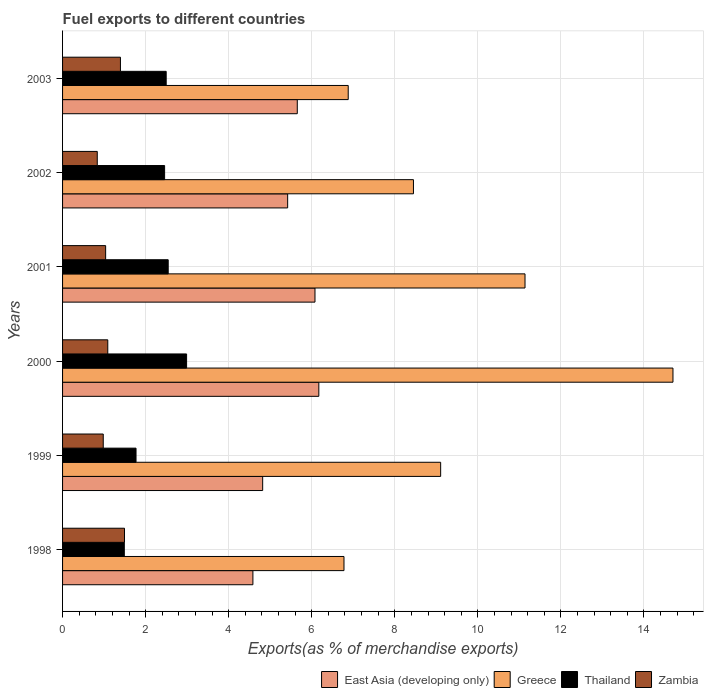How many bars are there on the 1st tick from the top?
Keep it short and to the point. 4. How many bars are there on the 4th tick from the bottom?
Offer a very short reply. 4. What is the percentage of exports to different countries in Greece in 1998?
Ensure brevity in your answer.  6.78. Across all years, what is the maximum percentage of exports to different countries in Thailand?
Keep it short and to the point. 2.99. Across all years, what is the minimum percentage of exports to different countries in Zambia?
Your response must be concise. 0.84. In which year was the percentage of exports to different countries in East Asia (developing only) minimum?
Keep it short and to the point. 1998. What is the total percentage of exports to different countries in Zambia in the graph?
Your answer should be compact. 6.83. What is the difference between the percentage of exports to different countries in East Asia (developing only) in 2001 and that in 2002?
Ensure brevity in your answer.  0.66. What is the difference between the percentage of exports to different countries in Zambia in 1998 and the percentage of exports to different countries in East Asia (developing only) in 2002?
Your answer should be compact. -3.93. What is the average percentage of exports to different countries in Zambia per year?
Your answer should be very brief. 1.14. In the year 2000, what is the difference between the percentage of exports to different countries in Greece and percentage of exports to different countries in Zambia?
Ensure brevity in your answer.  13.61. What is the ratio of the percentage of exports to different countries in Thailand in 1999 to that in 2002?
Give a very brief answer. 0.72. Is the percentage of exports to different countries in East Asia (developing only) in 1999 less than that in 2003?
Ensure brevity in your answer.  Yes. What is the difference between the highest and the second highest percentage of exports to different countries in Thailand?
Your answer should be compact. 0.44. What is the difference between the highest and the lowest percentage of exports to different countries in East Asia (developing only)?
Your answer should be compact. 1.59. In how many years, is the percentage of exports to different countries in East Asia (developing only) greater than the average percentage of exports to different countries in East Asia (developing only) taken over all years?
Give a very brief answer. 3. Is the sum of the percentage of exports to different countries in East Asia (developing only) in 1998 and 2002 greater than the maximum percentage of exports to different countries in Zambia across all years?
Give a very brief answer. Yes. Is it the case that in every year, the sum of the percentage of exports to different countries in East Asia (developing only) and percentage of exports to different countries in Greece is greater than the sum of percentage of exports to different countries in Thailand and percentage of exports to different countries in Zambia?
Your response must be concise. Yes. What does the 4th bar from the top in 1998 represents?
Offer a very short reply. East Asia (developing only). What does the 4th bar from the bottom in 2000 represents?
Offer a terse response. Zambia. Are all the bars in the graph horizontal?
Your answer should be very brief. Yes. How many years are there in the graph?
Ensure brevity in your answer.  6. What is the difference between two consecutive major ticks on the X-axis?
Your answer should be compact. 2. Does the graph contain grids?
Make the answer very short. Yes. How many legend labels are there?
Offer a terse response. 4. What is the title of the graph?
Give a very brief answer. Fuel exports to different countries. What is the label or title of the X-axis?
Ensure brevity in your answer.  Exports(as % of merchandise exports). What is the label or title of the Y-axis?
Provide a short and direct response. Years. What is the Exports(as % of merchandise exports) of East Asia (developing only) in 1998?
Provide a short and direct response. 4.58. What is the Exports(as % of merchandise exports) of Greece in 1998?
Ensure brevity in your answer.  6.78. What is the Exports(as % of merchandise exports) in Thailand in 1998?
Give a very brief answer. 1.49. What is the Exports(as % of merchandise exports) in Zambia in 1998?
Your response must be concise. 1.49. What is the Exports(as % of merchandise exports) of East Asia (developing only) in 1999?
Ensure brevity in your answer.  4.82. What is the Exports(as % of merchandise exports) of Greece in 1999?
Your answer should be very brief. 9.1. What is the Exports(as % of merchandise exports) of Thailand in 1999?
Give a very brief answer. 1.77. What is the Exports(as % of merchandise exports) in Zambia in 1999?
Provide a succinct answer. 0.98. What is the Exports(as % of merchandise exports) in East Asia (developing only) in 2000?
Offer a terse response. 6.17. What is the Exports(as % of merchandise exports) of Greece in 2000?
Give a very brief answer. 14.7. What is the Exports(as % of merchandise exports) of Thailand in 2000?
Make the answer very short. 2.99. What is the Exports(as % of merchandise exports) of Zambia in 2000?
Provide a short and direct response. 1.09. What is the Exports(as % of merchandise exports) of East Asia (developing only) in 2001?
Offer a terse response. 6.08. What is the Exports(as % of merchandise exports) of Greece in 2001?
Give a very brief answer. 11.14. What is the Exports(as % of merchandise exports) in Thailand in 2001?
Give a very brief answer. 2.54. What is the Exports(as % of merchandise exports) of Zambia in 2001?
Offer a very short reply. 1.04. What is the Exports(as % of merchandise exports) of East Asia (developing only) in 2002?
Your response must be concise. 5.42. What is the Exports(as % of merchandise exports) of Greece in 2002?
Offer a very short reply. 8.45. What is the Exports(as % of merchandise exports) of Thailand in 2002?
Offer a terse response. 2.46. What is the Exports(as % of merchandise exports) in Zambia in 2002?
Give a very brief answer. 0.84. What is the Exports(as % of merchandise exports) of East Asia (developing only) in 2003?
Make the answer very short. 5.65. What is the Exports(as % of merchandise exports) of Greece in 2003?
Keep it short and to the point. 6.88. What is the Exports(as % of merchandise exports) in Thailand in 2003?
Your answer should be very brief. 2.5. What is the Exports(as % of merchandise exports) in Zambia in 2003?
Ensure brevity in your answer.  1.39. Across all years, what is the maximum Exports(as % of merchandise exports) of East Asia (developing only)?
Your response must be concise. 6.17. Across all years, what is the maximum Exports(as % of merchandise exports) of Greece?
Offer a terse response. 14.7. Across all years, what is the maximum Exports(as % of merchandise exports) in Thailand?
Offer a very short reply. 2.99. Across all years, what is the maximum Exports(as % of merchandise exports) in Zambia?
Give a very brief answer. 1.49. Across all years, what is the minimum Exports(as % of merchandise exports) of East Asia (developing only)?
Give a very brief answer. 4.58. Across all years, what is the minimum Exports(as % of merchandise exports) of Greece?
Offer a terse response. 6.78. Across all years, what is the minimum Exports(as % of merchandise exports) of Thailand?
Your answer should be very brief. 1.49. Across all years, what is the minimum Exports(as % of merchandise exports) of Zambia?
Your answer should be very brief. 0.84. What is the total Exports(as % of merchandise exports) of East Asia (developing only) in the graph?
Make the answer very short. 32.72. What is the total Exports(as % of merchandise exports) of Greece in the graph?
Provide a short and direct response. 57.04. What is the total Exports(as % of merchandise exports) of Thailand in the graph?
Your response must be concise. 13.74. What is the total Exports(as % of merchandise exports) of Zambia in the graph?
Keep it short and to the point. 6.83. What is the difference between the Exports(as % of merchandise exports) of East Asia (developing only) in 1998 and that in 1999?
Provide a succinct answer. -0.24. What is the difference between the Exports(as % of merchandise exports) of Greece in 1998 and that in 1999?
Offer a terse response. -2.33. What is the difference between the Exports(as % of merchandise exports) in Thailand in 1998 and that in 1999?
Give a very brief answer. -0.28. What is the difference between the Exports(as % of merchandise exports) in Zambia in 1998 and that in 1999?
Your answer should be compact. 0.51. What is the difference between the Exports(as % of merchandise exports) in East Asia (developing only) in 1998 and that in 2000?
Give a very brief answer. -1.59. What is the difference between the Exports(as % of merchandise exports) of Greece in 1998 and that in 2000?
Ensure brevity in your answer.  -7.92. What is the difference between the Exports(as % of merchandise exports) in Thailand in 1998 and that in 2000?
Make the answer very short. -1.5. What is the difference between the Exports(as % of merchandise exports) in Zambia in 1998 and that in 2000?
Provide a succinct answer. 0.4. What is the difference between the Exports(as % of merchandise exports) of East Asia (developing only) in 1998 and that in 2001?
Make the answer very short. -1.5. What is the difference between the Exports(as % of merchandise exports) of Greece in 1998 and that in 2001?
Your answer should be compact. -4.36. What is the difference between the Exports(as % of merchandise exports) in Thailand in 1998 and that in 2001?
Provide a succinct answer. -1.06. What is the difference between the Exports(as % of merchandise exports) of Zambia in 1998 and that in 2001?
Keep it short and to the point. 0.45. What is the difference between the Exports(as % of merchandise exports) of East Asia (developing only) in 1998 and that in 2002?
Your response must be concise. -0.84. What is the difference between the Exports(as % of merchandise exports) of Greece in 1998 and that in 2002?
Provide a succinct answer. -1.67. What is the difference between the Exports(as % of merchandise exports) in Thailand in 1998 and that in 2002?
Ensure brevity in your answer.  -0.97. What is the difference between the Exports(as % of merchandise exports) of Zambia in 1998 and that in 2002?
Keep it short and to the point. 0.66. What is the difference between the Exports(as % of merchandise exports) in East Asia (developing only) in 1998 and that in 2003?
Offer a very short reply. -1.07. What is the difference between the Exports(as % of merchandise exports) of Greece in 1998 and that in 2003?
Offer a terse response. -0.1. What is the difference between the Exports(as % of merchandise exports) of Thailand in 1998 and that in 2003?
Provide a succinct answer. -1.01. What is the difference between the Exports(as % of merchandise exports) in Zambia in 1998 and that in 2003?
Keep it short and to the point. 0.1. What is the difference between the Exports(as % of merchandise exports) in East Asia (developing only) in 1999 and that in 2000?
Offer a very short reply. -1.35. What is the difference between the Exports(as % of merchandise exports) of Greece in 1999 and that in 2000?
Offer a very short reply. -5.59. What is the difference between the Exports(as % of merchandise exports) in Thailand in 1999 and that in 2000?
Your answer should be compact. -1.22. What is the difference between the Exports(as % of merchandise exports) in Zambia in 1999 and that in 2000?
Keep it short and to the point. -0.11. What is the difference between the Exports(as % of merchandise exports) in East Asia (developing only) in 1999 and that in 2001?
Offer a very short reply. -1.26. What is the difference between the Exports(as % of merchandise exports) of Greece in 1999 and that in 2001?
Provide a succinct answer. -2.03. What is the difference between the Exports(as % of merchandise exports) in Thailand in 1999 and that in 2001?
Provide a succinct answer. -0.77. What is the difference between the Exports(as % of merchandise exports) of Zambia in 1999 and that in 2001?
Keep it short and to the point. -0.06. What is the difference between the Exports(as % of merchandise exports) in East Asia (developing only) in 1999 and that in 2002?
Provide a short and direct response. -0.6. What is the difference between the Exports(as % of merchandise exports) in Greece in 1999 and that in 2002?
Your answer should be compact. 0.66. What is the difference between the Exports(as % of merchandise exports) in Thailand in 1999 and that in 2002?
Keep it short and to the point. -0.69. What is the difference between the Exports(as % of merchandise exports) of Zambia in 1999 and that in 2002?
Offer a terse response. 0.14. What is the difference between the Exports(as % of merchandise exports) of East Asia (developing only) in 1999 and that in 2003?
Offer a very short reply. -0.83. What is the difference between the Exports(as % of merchandise exports) of Greece in 1999 and that in 2003?
Your answer should be compact. 2.23. What is the difference between the Exports(as % of merchandise exports) of Thailand in 1999 and that in 2003?
Make the answer very short. -0.73. What is the difference between the Exports(as % of merchandise exports) in Zambia in 1999 and that in 2003?
Your answer should be very brief. -0.41. What is the difference between the Exports(as % of merchandise exports) of East Asia (developing only) in 2000 and that in 2001?
Your response must be concise. 0.09. What is the difference between the Exports(as % of merchandise exports) in Greece in 2000 and that in 2001?
Offer a very short reply. 3.56. What is the difference between the Exports(as % of merchandise exports) of Thailand in 2000 and that in 2001?
Offer a terse response. 0.44. What is the difference between the Exports(as % of merchandise exports) in Zambia in 2000 and that in 2001?
Give a very brief answer. 0.05. What is the difference between the Exports(as % of merchandise exports) of East Asia (developing only) in 2000 and that in 2002?
Provide a short and direct response. 0.75. What is the difference between the Exports(as % of merchandise exports) in Greece in 2000 and that in 2002?
Offer a terse response. 6.25. What is the difference between the Exports(as % of merchandise exports) of Thailand in 2000 and that in 2002?
Ensure brevity in your answer.  0.53. What is the difference between the Exports(as % of merchandise exports) of Zambia in 2000 and that in 2002?
Ensure brevity in your answer.  0.25. What is the difference between the Exports(as % of merchandise exports) of East Asia (developing only) in 2000 and that in 2003?
Offer a very short reply. 0.52. What is the difference between the Exports(as % of merchandise exports) in Greece in 2000 and that in 2003?
Your answer should be very brief. 7.82. What is the difference between the Exports(as % of merchandise exports) in Thailand in 2000 and that in 2003?
Provide a succinct answer. 0.49. What is the difference between the Exports(as % of merchandise exports) of Zambia in 2000 and that in 2003?
Keep it short and to the point. -0.3. What is the difference between the Exports(as % of merchandise exports) of East Asia (developing only) in 2001 and that in 2002?
Offer a terse response. 0.66. What is the difference between the Exports(as % of merchandise exports) in Greece in 2001 and that in 2002?
Provide a succinct answer. 2.69. What is the difference between the Exports(as % of merchandise exports) of Thailand in 2001 and that in 2002?
Give a very brief answer. 0.09. What is the difference between the Exports(as % of merchandise exports) of Zambia in 2001 and that in 2002?
Your answer should be compact. 0.2. What is the difference between the Exports(as % of merchandise exports) of East Asia (developing only) in 2001 and that in 2003?
Offer a very short reply. 0.43. What is the difference between the Exports(as % of merchandise exports) of Greece in 2001 and that in 2003?
Your answer should be very brief. 4.26. What is the difference between the Exports(as % of merchandise exports) of Thailand in 2001 and that in 2003?
Give a very brief answer. 0.05. What is the difference between the Exports(as % of merchandise exports) of Zambia in 2001 and that in 2003?
Provide a short and direct response. -0.36. What is the difference between the Exports(as % of merchandise exports) of East Asia (developing only) in 2002 and that in 2003?
Your response must be concise. -0.23. What is the difference between the Exports(as % of merchandise exports) in Greece in 2002 and that in 2003?
Give a very brief answer. 1.57. What is the difference between the Exports(as % of merchandise exports) of Thailand in 2002 and that in 2003?
Your answer should be compact. -0.04. What is the difference between the Exports(as % of merchandise exports) in Zambia in 2002 and that in 2003?
Make the answer very short. -0.56. What is the difference between the Exports(as % of merchandise exports) in East Asia (developing only) in 1998 and the Exports(as % of merchandise exports) in Greece in 1999?
Your response must be concise. -4.52. What is the difference between the Exports(as % of merchandise exports) of East Asia (developing only) in 1998 and the Exports(as % of merchandise exports) of Thailand in 1999?
Provide a short and direct response. 2.81. What is the difference between the Exports(as % of merchandise exports) in East Asia (developing only) in 1998 and the Exports(as % of merchandise exports) in Zambia in 1999?
Offer a very short reply. 3.6. What is the difference between the Exports(as % of merchandise exports) of Greece in 1998 and the Exports(as % of merchandise exports) of Thailand in 1999?
Your answer should be compact. 5.01. What is the difference between the Exports(as % of merchandise exports) in Greece in 1998 and the Exports(as % of merchandise exports) in Zambia in 1999?
Your answer should be very brief. 5.8. What is the difference between the Exports(as % of merchandise exports) of Thailand in 1998 and the Exports(as % of merchandise exports) of Zambia in 1999?
Ensure brevity in your answer.  0.51. What is the difference between the Exports(as % of merchandise exports) in East Asia (developing only) in 1998 and the Exports(as % of merchandise exports) in Greece in 2000?
Offer a terse response. -10.12. What is the difference between the Exports(as % of merchandise exports) in East Asia (developing only) in 1998 and the Exports(as % of merchandise exports) in Thailand in 2000?
Ensure brevity in your answer.  1.6. What is the difference between the Exports(as % of merchandise exports) of East Asia (developing only) in 1998 and the Exports(as % of merchandise exports) of Zambia in 2000?
Offer a terse response. 3.49. What is the difference between the Exports(as % of merchandise exports) of Greece in 1998 and the Exports(as % of merchandise exports) of Thailand in 2000?
Offer a terse response. 3.79. What is the difference between the Exports(as % of merchandise exports) in Greece in 1998 and the Exports(as % of merchandise exports) in Zambia in 2000?
Your answer should be very brief. 5.69. What is the difference between the Exports(as % of merchandise exports) in Thailand in 1998 and the Exports(as % of merchandise exports) in Zambia in 2000?
Ensure brevity in your answer.  0.4. What is the difference between the Exports(as % of merchandise exports) in East Asia (developing only) in 1998 and the Exports(as % of merchandise exports) in Greece in 2001?
Offer a terse response. -6.55. What is the difference between the Exports(as % of merchandise exports) in East Asia (developing only) in 1998 and the Exports(as % of merchandise exports) in Thailand in 2001?
Your answer should be very brief. 2.04. What is the difference between the Exports(as % of merchandise exports) of East Asia (developing only) in 1998 and the Exports(as % of merchandise exports) of Zambia in 2001?
Offer a very short reply. 3.55. What is the difference between the Exports(as % of merchandise exports) of Greece in 1998 and the Exports(as % of merchandise exports) of Thailand in 2001?
Provide a succinct answer. 4.23. What is the difference between the Exports(as % of merchandise exports) in Greece in 1998 and the Exports(as % of merchandise exports) in Zambia in 2001?
Your response must be concise. 5.74. What is the difference between the Exports(as % of merchandise exports) of Thailand in 1998 and the Exports(as % of merchandise exports) of Zambia in 2001?
Ensure brevity in your answer.  0.45. What is the difference between the Exports(as % of merchandise exports) in East Asia (developing only) in 1998 and the Exports(as % of merchandise exports) in Greece in 2002?
Make the answer very short. -3.87. What is the difference between the Exports(as % of merchandise exports) in East Asia (developing only) in 1998 and the Exports(as % of merchandise exports) in Thailand in 2002?
Provide a short and direct response. 2.13. What is the difference between the Exports(as % of merchandise exports) of East Asia (developing only) in 1998 and the Exports(as % of merchandise exports) of Zambia in 2002?
Offer a very short reply. 3.75. What is the difference between the Exports(as % of merchandise exports) of Greece in 1998 and the Exports(as % of merchandise exports) of Thailand in 2002?
Provide a succinct answer. 4.32. What is the difference between the Exports(as % of merchandise exports) of Greece in 1998 and the Exports(as % of merchandise exports) of Zambia in 2002?
Give a very brief answer. 5.94. What is the difference between the Exports(as % of merchandise exports) in Thailand in 1998 and the Exports(as % of merchandise exports) in Zambia in 2002?
Ensure brevity in your answer.  0.65. What is the difference between the Exports(as % of merchandise exports) of East Asia (developing only) in 1998 and the Exports(as % of merchandise exports) of Greece in 2003?
Offer a very short reply. -2.3. What is the difference between the Exports(as % of merchandise exports) of East Asia (developing only) in 1998 and the Exports(as % of merchandise exports) of Thailand in 2003?
Provide a succinct answer. 2.09. What is the difference between the Exports(as % of merchandise exports) of East Asia (developing only) in 1998 and the Exports(as % of merchandise exports) of Zambia in 2003?
Make the answer very short. 3.19. What is the difference between the Exports(as % of merchandise exports) in Greece in 1998 and the Exports(as % of merchandise exports) in Thailand in 2003?
Your answer should be compact. 4.28. What is the difference between the Exports(as % of merchandise exports) in Greece in 1998 and the Exports(as % of merchandise exports) in Zambia in 2003?
Provide a succinct answer. 5.38. What is the difference between the Exports(as % of merchandise exports) in Thailand in 1998 and the Exports(as % of merchandise exports) in Zambia in 2003?
Your answer should be compact. 0.09. What is the difference between the Exports(as % of merchandise exports) in East Asia (developing only) in 1999 and the Exports(as % of merchandise exports) in Greece in 2000?
Your answer should be very brief. -9.88. What is the difference between the Exports(as % of merchandise exports) in East Asia (developing only) in 1999 and the Exports(as % of merchandise exports) in Thailand in 2000?
Ensure brevity in your answer.  1.83. What is the difference between the Exports(as % of merchandise exports) in East Asia (developing only) in 1999 and the Exports(as % of merchandise exports) in Zambia in 2000?
Make the answer very short. 3.73. What is the difference between the Exports(as % of merchandise exports) of Greece in 1999 and the Exports(as % of merchandise exports) of Thailand in 2000?
Give a very brief answer. 6.12. What is the difference between the Exports(as % of merchandise exports) of Greece in 1999 and the Exports(as % of merchandise exports) of Zambia in 2000?
Your response must be concise. 8.02. What is the difference between the Exports(as % of merchandise exports) of Thailand in 1999 and the Exports(as % of merchandise exports) of Zambia in 2000?
Provide a short and direct response. 0.68. What is the difference between the Exports(as % of merchandise exports) of East Asia (developing only) in 1999 and the Exports(as % of merchandise exports) of Greece in 2001?
Your response must be concise. -6.32. What is the difference between the Exports(as % of merchandise exports) of East Asia (developing only) in 1999 and the Exports(as % of merchandise exports) of Thailand in 2001?
Your answer should be very brief. 2.27. What is the difference between the Exports(as % of merchandise exports) of East Asia (developing only) in 1999 and the Exports(as % of merchandise exports) of Zambia in 2001?
Your answer should be very brief. 3.78. What is the difference between the Exports(as % of merchandise exports) of Greece in 1999 and the Exports(as % of merchandise exports) of Thailand in 2001?
Your response must be concise. 6.56. What is the difference between the Exports(as % of merchandise exports) of Greece in 1999 and the Exports(as % of merchandise exports) of Zambia in 2001?
Provide a short and direct response. 8.07. What is the difference between the Exports(as % of merchandise exports) of Thailand in 1999 and the Exports(as % of merchandise exports) of Zambia in 2001?
Make the answer very short. 0.73. What is the difference between the Exports(as % of merchandise exports) in East Asia (developing only) in 1999 and the Exports(as % of merchandise exports) in Greece in 2002?
Keep it short and to the point. -3.63. What is the difference between the Exports(as % of merchandise exports) in East Asia (developing only) in 1999 and the Exports(as % of merchandise exports) in Thailand in 2002?
Offer a terse response. 2.36. What is the difference between the Exports(as % of merchandise exports) of East Asia (developing only) in 1999 and the Exports(as % of merchandise exports) of Zambia in 2002?
Offer a very short reply. 3.98. What is the difference between the Exports(as % of merchandise exports) of Greece in 1999 and the Exports(as % of merchandise exports) of Thailand in 2002?
Give a very brief answer. 6.65. What is the difference between the Exports(as % of merchandise exports) in Greece in 1999 and the Exports(as % of merchandise exports) in Zambia in 2002?
Offer a very short reply. 8.27. What is the difference between the Exports(as % of merchandise exports) in Thailand in 1999 and the Exports(as % of merchandise exports) in Zambia in 2002?
Keep it short and to the point. 0.93. What is the difference between the Exports(as % of merchandise exports) in East Asia (developing only) in 1999 and the Exports(as % of merchandise exports) in Greece in 2003?
Provide a succinct answer. -2.06. What is the difference between the Exports(as % of merchandise exports) of East Asia (developing only) in 1999 and the Exports(as % of merchandise exports) of Thailand in 2003?
Your answer should be compact. 2.32. What is the difference between the Exports(as % of merchandise exports) in East Asia (developing only) in 1999 and the Exports(as % of merchandise exports) in Zambia in 2003?
Provide a short and direct response. 3.42. What is the difference between the Exports(as % of merchandise exports) of Greece in 1999 and the Exports(as % of merchandise exports) of Thailand in 2003?
Keep it short and to the point. 6.61. What is the difference between the Exports(as % of merchandise exports) of Greece in 1999 and the Exports(as % of merchandise exports) of Zambia in 2003?
Offer a terse response. 7.71. What is the difference between the Exports(as % of merchandise exports) in Thailand in 1999 and the Exports(as % of merchandise exports) in Zambia in 2003?
Your answer should be very brief. 0.38. What is the difference between the Exports(as % of merchandise exports) of East Asia (developing only) in 2000 and the Exports(as % of merchandise exports) of Greece in 2001?
Your answer should be compact. -4.96. What is the difference between the Exports(as % of merchandise exports) of East Asia (developing only) in 2000 and the Exports(as % of merchandise exports) of Thailand in 2001?
Provide a succinct answer. 3.63. What is the difference between the Exports(as % of merchandise exports) in East Asia (developing only) in 2000 and the Exports(as % of merchandise exports) in Zambia in 2001?
Provide a short and direct response. 5.13. What is the difference between the Exports(as % of merchandise exports) in Greece in 2000 and the Exports(as % of merchandise exports) in Thailand in 2001?
Provide a succinct answer. 12.15. What is the difference between the Exports(as % of merchandise exports) of Greece in 2000 and the Exports(as % of merchandise exports) of Zambia in 2001?
Your response must be concise. 13.66. What is the difference between the Exports(as % of merchandise exports) of Thailand in 2000 and the Exports(as % of merchandise exports) of Zambia in 2001?
Keep it short and to the point. 1.95. What is the difference between the Exports(as % of merchandise exports) in East Asia (developing only) in 2000 and the Exports(as % of merchandise exports) in Greece in 2002?
Ensure brevity in your answer.  -2.28. What is the difference between the Exports(as % of merchandise exports) in East Asia (developing only) in 2000 and the Exports(as % of merchandise exports) in Thailand in 2002?
Your answer should be compact. 3.71. What is the difference between the Exports(as % of merchandise exports) in East Asia (developing only) in 2000 and the Exports(as % of merchandise exports) in Zambia in 2002?
Your answer should be very brief. 5.33. What is the difference between the Exports(as % of merchandise exports) of Greece in 2000 and the Exports(as % of merchandise exports) of Thailand in 2002?
Offer a very short reply. 12.24. What is the difference between the Exports(as % of merchandise exports) in Greece in 2000 and the Exports(as % of merchandise exports) in Zambia in 2002?
Your response must be concise. 13.86. What is the difference between the Exports(as % of merchandise exports) in Thailand in 2000 and the Exports(as % of merchandise exports) in Zambia in 2002?
Offer a very short reply. 2.15. What is the difference between the Exports(as % of merchandise exports) of East Asia (developing only) in 2000 and the Exports(as % of merchandise exports) of Greece in 2003?
Provide a succinct answer. -0.71. What is the difference between the Exports(as % of merchandise exports) in East Asia (developing only) in 2000 and the Exports(as % of merchandise exports) in Thailand in 2003?
Keep it short and to the point. 3.68. What is the difference between the Exports(as % of merchandise exports) of East Asia (developing only) in 2000 and the Exports(as % of merchandise exports) of Zambia in 2003?
Make the answer very short. 4.78. What is the difference between the Exports(as % of merchandise exports) of Greece in 2000 and the Exports(as % of merchandise exports) of Thailand in 2003?
Offer a very short reply. 12.2. What is the difference between the Exports(as % of merchandise exports) in Greece in 2000 and the Exports(as % of merchandise exports) in Zambia in 2003?
Ensure brevity in your answer.  13.3. What is the difference between the Exports(as % of merchandise exports) of Thailand in 2000 and the Exports(as % of merchandise exports) of Zambia in 2003?
Offer a terse response. 1.59. What is the difference between the Exports(as % of merchandise exports) in East Asia (developing only) in 2001 and the Exports(as % of merchandise exports) in Greece in 2002?
Offer a very short reply. -2.37. What is the difference between the Exports(as % of merchandise exports) in East Asia (developing only) in 2001 and the Exports(as % of merchandise exports) in Thailand in 2002?
Keep it short and to the point. 3.62. What is the difference between the Exports(as % of merchandise exports) in East Asia (developing only) in 2001 and the Exports(as % of merchandise exports) in Zambia in 2002?
Your response must be concise. 5.24. What is the difference between the Exports(as % of merchandise exports) of Greece in 2001 and the Exports(as % of merchandise exports) of Thailand in 2002?
Your answer should be compact. 8.68. What is the difference between the Exports(as % of merchandise exports) of Greece in 2001 and the Exports(as % of merchandise exports) of Zambia in 2002?
Give a very brief answer. 10.3. What is the difference between the Exports(as % of merchandise exports) of Thailand in 2001 and the Exports(as % of merchandise exports) of Zambia in 2002?
Ensure brevity in your answer.  1.71. What is the difference between the Exports(as % of merchandise exports) of East Asia (developing only) in 2001 and the Exports(as % of merchandise exports) of Greece in 2003?
Ensure brevity in your answer.  -0.8. What is the difference between the Exports(as % of merchandise exports) in East Asia (developing only) in 2001 and the Exports(as % of merchandise exports) in Thailand in 2003?
Offer a terse response. 3.58. What is the difference between the Exports(as % of merchandise exports) of East Asia (developing only) in 2001 and the Exports(as % of merchandise exports) of Zambia in 2003?
Keep it short and to the point. 4.68. What is the difference between the Exports(as % of merchandise exports) of Greece in 2001 and the Exports(as % of merchandise exports) of Thailand in 2003?
Ensure brevity in your answer.  8.64. What is the difference between the Exports(as % of merchandise exports) in Greece in 2001 and the Exports(as % of merchandise exports) in Zambia in 2003?
Make the answer very short. 9.74. What is the difference between the Exports(as % of merchandise exports) in Thailand in 2001 and the Exports(as % of merchandise exports) in Zambia in 2003?
Provide a short and direct response. 1.15. What is the difference between the Exports(as % of merchandise exports) of East Asia (developing only) in 2002 and the Exports(as % of merchandise exports) of Greece in 2003?
Provide a succinct answer. -1.46. What is the difference between the Exports(as % of merchandise exports) of East Asia (developing only) in 2002 and the Exports(as % of merchandise exports) of Thailand in 2003?
Offer a terse response. 2.92. What is the difference between the Exports(as % of merchandise exports) of East Asia (developing only) in 2002 and the Exports(as % of merchandise exports) of Zambia in 2003?
Offer a terse response. 4.03. What is the difference between the Exports(as % of merchandise exports) of Greece in 2002 and the Exports(as % of merchandise exports) of Thailand in 2003?
Provide a short and direct response. 5.95. What is the difference between the Exports(as % of merchandise exports) of Greece in 2002 and the Exports(as % of merchandise exports) of Zambia in 2003?
Your answer should be very brief. 7.06. What is the difference between the Exports(as % of merchandise exports) of Thailand in 2002 and the Exports(as % of merchandise exports) of Zambia in 2003?
Provide a short and direct response. 1.06. What is the average Exports(as % of merchandise exports) in East Asia (developing only) per year?
Your response must be concise. 5.45. What is the average Exports(as % of merchandise exports) of Greece per year?
Offer a terse response. 9.51. What is the average Exports(as % of merchandise exports) of Thailand per year?
Give a very brief answer. 2.29. What is the average Exports(as % of merchandise exports) of Zambia per year?
Your answer should be compact. 1.14. In the year 1998, what is the difference between the Exports(as % of merchandise exports) in East Asia (developing only) and Exports(as % of merchandise exports) in Greece?
Offer a very short reply. -2.19. In the year 1998, what is the difference between the Exports(as % of merchandise exports) of East Asia (developing only) and Exports(as % of merchandise exports) of Thailand?
Provide a succinct answer. 3.1. In the year 1998, what is the difference between the Exports(as % of merchandise exports) in East Asia (developing only) and Exports(as % of merchandise exports) in Zambia?
Offer a terse response. 3.09. In the year 1998, what is the difference between the Exports(as % of merchandise exports) of Greece and Exports(as % of merchandise exports) of Thailand?
Offer a very short reply. 5.29. In the year 1998, what is the difference between the Exports(as % of merchandise exports) of Greece and Exports(as % of merchandise exports) of Zambia?
Your answer should be compact. 5.29. In the year 1998, what is the difference between the Exports(as % of merchandise exports) of Thailand and Exports(as % of merchandise exports) of Zambia?
Your response must be concise. -0. In the year 1999, what is the difference between the Exports(as % of merchandise exports) in East Asia (developing only) and Exports(as % of merchandise exports) in Greece?
Your answer should be compact. -4.29. In the year 1999, what is the difference between the Exports(as % of merchandise exports) of East Asia (developing only) and Exports(as % of merchandise exports) of Thailand?
Your response must be concise. 3.05. In the year 1999, what is the difference between the Exports(as % of merchandise exports) of East Asia (developing only) and Exports(as % of merchandise exports) of Zambia?
Your response must be concise. 3.84. In the year 1999, what is the difference between the Exports(as % of merchandise exports) in Greece and Exports(as % of merchandise exports) in Thailand?
Your answer should be compact. 7.34. In the year 1999, what is the difference between the Exports(as % of merchandise exports) in Greece and Exports(as % of merchandise exports) in Zambia?
Provide a short and direct response. 8.12. In the year 1999, what is the difference between the Exports(as % of merchandise exports) of Thailand and Exports(as % of merchandise exports) of Zambia?
Offer a terse response. 0.79. In the year 2000, what is the difference between the Exports(as % of merchandise exports) in East Asia (developing only) and Exports(as % of merchandise exports) in Greece?
Your answer should be very brief. -8.53. In the year 2000, what is the difference between the Exports(as % of merchandise exports) in East Asia (developing only) and Exports(as % of merchandise exports) in Thailand?
Your answer should be very brief. 3.18. In the year 2000, what is the difference between the Exports(as % of merchandise exports) in East Asia (developing only) and Exports(as % of merchandise exports) in Zambia?
Keep it short and to the point. 5.08. In the year 2000, what is the difference between the Exports(as % of merchandise exports) in Greece and Exports(as % of merchandise exports) in Thailand?
Provide a short and direct response. 11.71. In the year 2000, what is the difference between the Exports(as % of merchandise exports) in Greece and Exports(as % of merchandise exports) in Zambia?
Your answer should be very brief. 13.61. In the year 2000, what is the difference between the Exports(as % of merchandise exports) in Thailand and Exports(as % of merchandise exports) in Zambia?
Give a very brief answer. 1.9. In the year 2001, what is the difference between the Exports(as % of merchandise exports) of East Asia (developing only) and Exports(as % of merchandise exports) of Greece?
Offer a very short reply. -5.06. In the year 2001, what is the difference between the Exports(as % of merchandise exports) in East Asia (developing only) and Exports(as % of merchandise exports) in Thailand?
Ensure brevity in your answer.  3.53. In the year 2001, what is the difference between the Exports(as % of merchandise exports) in East Asia (developing only) and Exports(as % of merchandise exports) in Zambia?
Ensure brevity in your answer.  5.04. In the year 2001, what is the difference between the Exports(as % of merchandise exports) of Greece and Exports(as % of merchandise exports) of Thailand?
Provide a succinct answer. 8.59. In the year 2001, what is the difference between the Exports(as % of merchandise exports) in Greece and Exports(as % of merchandise exports) in Zambia?
Make the answer very short. 10.1. In the year 2001, what is the difference between the Exports(as % of merchandise exports) of Thailand and Exports(as % of merchandise exports) of Zambia?
Your answer should be compact. 1.51. In the year 2002, what is the difference between the Exports(as % of merchandise exports) of East Asia (developing only) and Exports(as % of merchandise exports) of Greece?
Give a very brief answer. -3.03. In the year 2002, what is the difference between the Exports(as % of merchandise exports) of East Asia (developing only) and Exports(as % of merchandise exports) of Thailand?
Your response must be concise. 2.96. In the year 2002, what is the difference between the Exports(as % of merchandise exports) of East Asia (developing only) and Exports(as % of merchandise exports) of Zambia?
Make the answer very short. 4.58. In the year 2002, what is the difference between the Exports(as % of merchandise exports) in Greece and Exports(as % of merchandise exports) in Thailand?
Your answer should be very brief. 5.99. In the year 2002, what is the difference between the Exports(as % of merchandise exports) of Greece and Exports(as % of merchandise exports) of Zambia?
Your answer should be compact. 7.61. In the year 2002, what is the difference between the Exports(as % of merchandise exports) in Thailand and Exports(as % of merchandise exports) in Zambia?
Give a very brief answer. 1.62. In the year 2003, what is the difference between the Exports(as % of merchandise exports) of East Asia (developing only) and Exports(as % of merchandise exports) of Greece?
Give a very brief answer. -1.23. In the year 2003, what is the difference between the Exports(as % of merchandise exports) in East Asia (developing only) and Exports(as % of merchandise exports) in Thailand?
Provide a short and direct response. 3.16. In the year 2003, what is the difference between the Exports(as % of merchandise exports) in East Asia (developing only) and Exports(as % of merchandise exports) in Zambia?
Your response must be concise. 4.26. In the year 2003, what is the difference between the Exports(as % of merchandise exports) of Greece and Exports(as % of merchandise exports) of Thailand?
Give a very brief answer. 4.38. In the year 2003, what is the difference between the Exports(as % of merchandise exports) in Greece and Exports(as % of merchandise exports) in Zambia?
Your answer should be compact. 5.49. In the year 2003, what is the difference between the Exports(as % of merchandise exports) in Thailand and Exports(as % of merchandise exports) in Zambia?
Your answer should be compact. 1.1. What is the ratio of the Exports(as % of merchandise exports) in East Asia (developing only) in 1998 to that in 1999?
Provide a succinct answer. 0.95. What is the ratio of the Exports(as % of merchandise exports) of Greece in 1998 to that in 1999?
Your answer should be very brief. 0.74. What is the ratio of the Exports(as % of merchandise exports) of Thailand in 1998 to that in 1999?
Keep it short and to the point. 0.84. What is the ratio of the Exports(as % of merchandise exports) in Zambia in 1998 to that in 1999?
Ensure brevity in your answer.  1.52. What is the ratio of the Exports(as % of merchandise exports) of East Asia (developing only) in 1998 to that in 2000?
Offer a terse response. 0.74. What is the ratio of the Exports(as % of merchandise exports) of Greece in 1998 to that in 2000?
Your answer should be very brief. 0.46. What is the ratio of the Exports(as % of merchandise exports) in Thailand in 1998 to that in 2000?
Your answer should be compact. 0.5. What is the ratio of the Exports(as % of merchandise exports) of Zambia in 1998 to that in 2000?
Provide a succinct answer. 1.37. What is the ratio of the Exports(as % of merchandise exports) of East Asia (developing only) in 1998 to that in 2001?
Make the answer very short. 0.75. What is the ratio of the Exports(as % of merchandise exports) of Greece in 1998 to that in 2001?
Give a very brief answer. 0.61. What is the ratio of the Exports(as % of merchandise exports) of Thailand in 1998 to that in 2001?
Make the answer very short. 0.58. What is the ratio of the Exports(as % of merchandise exports) in Zambia in 1998 to that in 2001?
Your response must be concise. 1.44. What is the ratio of the Exports(as % of merchandise exports) of East Asia (developing only) in 1998 to that in 2002?
Your response must be concise. 0.85. What is the ratio of the Exports(as % of merchandise exports) in Greece in 1998 to that in 2002?
Make the answer very short. 0.8. What is the ratio of the Exports(as % of merchandise exports) in Thailand in 1998 to that in 2002?
Offer a very short reply. 0.6. What is the ratio of the Exports(as % of merchandise exports) of Zambia in 1998 to that in 2002?
Your response must be concise. 1.78. What is the ratio of the Exports(as % of merchandise exports) of East Asia (developing only) in 1998 to that in 2003?
Make the answer very short. 0.81. What is the ratio of the Exports(as % of merchandise exports) in Greece in 1998 to that in 2003?
Provide a succinct answer. 0.99. What is the ratio of the Exports(as % of merchandise exports) of Thailand in 1998 to that in 2003?
Make the answer very short. 0.6. What is the ratio of the Exports(as % of merchandise exports) of Zambia in 1998 to that in 2003?
Offer a terse response. 1.07. What is the ratio of the Exports(as % of merchandise exports) of East Asia (developing only) in 1999 to that in 2000?
Provide a succinct answer. 0.78. What is the ratio of the Exports(as % of merchandise exports) of Greece in 1999 to that in 2000?
Provide a succinct answer. 0.62. What is the ratio of the Exports(as % of merchandise exports) of Thailand in 1999 to that in 2000?
Your answer should be compact. 0.59. What is the ratio of the Exports(as % of merchandise exports) in Zambia in 1999 to that in 2000?
Keep it short and to the point. 0.9. What is the ratio of the Exports(as % of merchandise exports) in East Asia (developing only) in 1999 to that in 2001?
Ensure brevity in your answer.  0.79. What is the ratio of the Exports(as % of merchandise exports) in Greece in 1999 to that in 2001?
Give a very brief answer. 0.82. What is the ratio of the Exports(as % of merchandise exports) of Thailand in 1999 to that in 2001?
Ensure brevity in your answer.  0.7. What is the ratio of the Exports(as % of merchandise exports) in Zambia in 1999 to that in 2001?
Your answer should be compact. 0.94. What is the ratio of the Exports(as % of merchandise exports) in East Asia (developing only) in 1999 to that in 2002?
Ensure brevity in your answer.  0.89. What is the ratio of the Exports(as % of merchandise exports) in Greece in 1999 to that in 2002?
Your answer should be compact. 1.08. What is the ratio of the Exports(as % of merchandise exports) of Thailand in 1999 to that in 2002?
Offer a terse response. 0.72. What is the ratio of the Exports(as % of merchandise exports) of Zambia in 1999 to that in 2002?
Keep it short and to the point. 1.17. What is the ratio of the Exports(as % of merchandise exports) in East Asia (developing only) in 1999 to that in 2003?
Make the answer very short. 0.85. What is the ratio of the Exports(as % of merchandise exports) in Greece in 1999 to that in 2003?
Offer a very short reply. 1.32. What is the ratio of the Exports(as % of merchandise exports) in Thailand in 1999 to that in 2003?
Your answer should be compact. 0.71. What is the ratio of the Exports(as % of merchandise exports) of Zambia in 1999 to that in 2003?
Your answer should be compact. 0.7. What is the ratio of the Exports(as % of merchandise exports) in East Asia (developing only) in 2000 to that in 2001?
Make the answer very short. 1.02. What is the ratio of the Exports(as % of merchandise exports) of Greece in 2000 to that in 2001?
Your response must be concise. 1.32. What is the ratio of the Exports(as % of merchandise exports) of Thailand in 2000 to that in 2001?
Give a very brief answer. 1.17. What is the ratio of the Exports(as % of merchandise exports) of Zambia in 2000 to that in 2001?
Your answer should be compact. 1.05. What is the ratio of the Exports(as % of merchandise exports) of East Asia (developing only) in 2000 to that in 2002?
Offer a very short reply. 1.14. What is the ratio of the Exports(as % of merchandise exports) in Greece in 2000 to that in 2002?
Offer a terse response. 1.74. What is the ratio of the Exports(as % of merchandise exports) of Thailand in 2000 to that in 2002?
Offer a terse response. 1.22. What is the ratio of the Exports(as % of merchandise exports) in Zambia in 2000 to that in 2002?
Ensure brevity in your answer.  1.3. What is the ratio of the Exports(as % of merchandise exports) of East Asia (developing only) in 2000 to that in 2003?
Your response must be concise. 1.09. What is the ratio of the Exports(as % of merchandise exports) of Greece in 2000 to that in 2003?
Offer a terse response. 2.14. What is the ratio of the Exports(as % of merchandise exports) in Thailand in 2000 to that in 2003?
Provide a short and direct response. 1.2. What is the ratio of the Exports(as % of merchandise exports) in Zambia in 2000 to that in 2003?
Give a very brief answer. 0.78. What is the ratio of the Exports(as % of merchandise exports) in East Asia (developing only) in 2001 to that in 2002?
Give a very brief answer. 1.12. What is the ratio of the Exports(as % of merchandise exports) of Greece in 2001 to that in 2002?
Offer a terse response. 1.32. What is the ratio of the Exports(as % of merchandise exports) in Thailand in 2001 to that in 2002?
Make the answer very short. 1.04. What is the ratio of the Exports(as % of merchandise exports) of Zambia in 2001 to that in 2002?
Keep it short and to the point. 1.24. What is the ratio of the Exports(as % of merchandise exports) in East Asia (developing only) in 2001 to that in 2003?
Provide a succinct answer. 1.08. What is the ratio of the Exports(as % of merchandise exports) in Greece in 2001 to that in 2003?
Your answer should be compact. 1.62. What is the ratio of the Exports(as % of merchandise exports) of Thailand in 2001 to that in 2003?
Offer a terse response. 1.02. What is the ratio of the Exports(as % of merchandise exports) in Zambia in 2001 to that in 2003?
Your answer should be compact. 0.74. What is the ratio of the Exports(as % of merchandise exports) in East Asia (developing only) in 2002 to that in 2003?
Offer a very short reply. 0.96. What is the ratio of the Exports(as % of merchandise exports) of Greece in 2002 to that in 2003?
Offer a very short reply. 1.23. What is the ratio of the Exports(as % of merchandise exports) in Thailand in 2002 to that in 2003?
Provide a succinct answer. 0.98. What is the ratio of the Exports(as % of merchandise exports) of Zambia in 2002 to that in 2003?
Make the answer very short. 0.6. What is the difference between the highest and the second highest Exports(as % of merchandise exports) in East Asia (developing only)?
Offer a very short reply. 0.09. What is the difference between the highest and the second highest Exports(as % of merchandise exports) of Greece?
Provide a short and direct response. 3.56. What is the difference between the highest and the second highest Exports(as % of merchandise exports) in Thailand?
Offer a very short reply. 0.44. What is the difference between the highest and the second highest Exports(as % of merchandise exports) of Zambia?
Offer a terse response. 0.1. What is the difference between the highest and the lowest Exports(as % of merchandise exports) in East Asia (developing only)?
Ensure brevity in your answer.  1.59. What is the difference between the highest and the lowest Exports(as % of merchandise exports) of Greece?
Keep it short and to the point. 7.92. What is the difference between the highest and the lowest Exports(as % of merchandise exports) of Thailand?
Keep it short and to the point. 1.5. What is the difference between the highest and the lowest Exports(as % of merchandise exports) of Zambia?
Offer a very short reply. 0.66. 